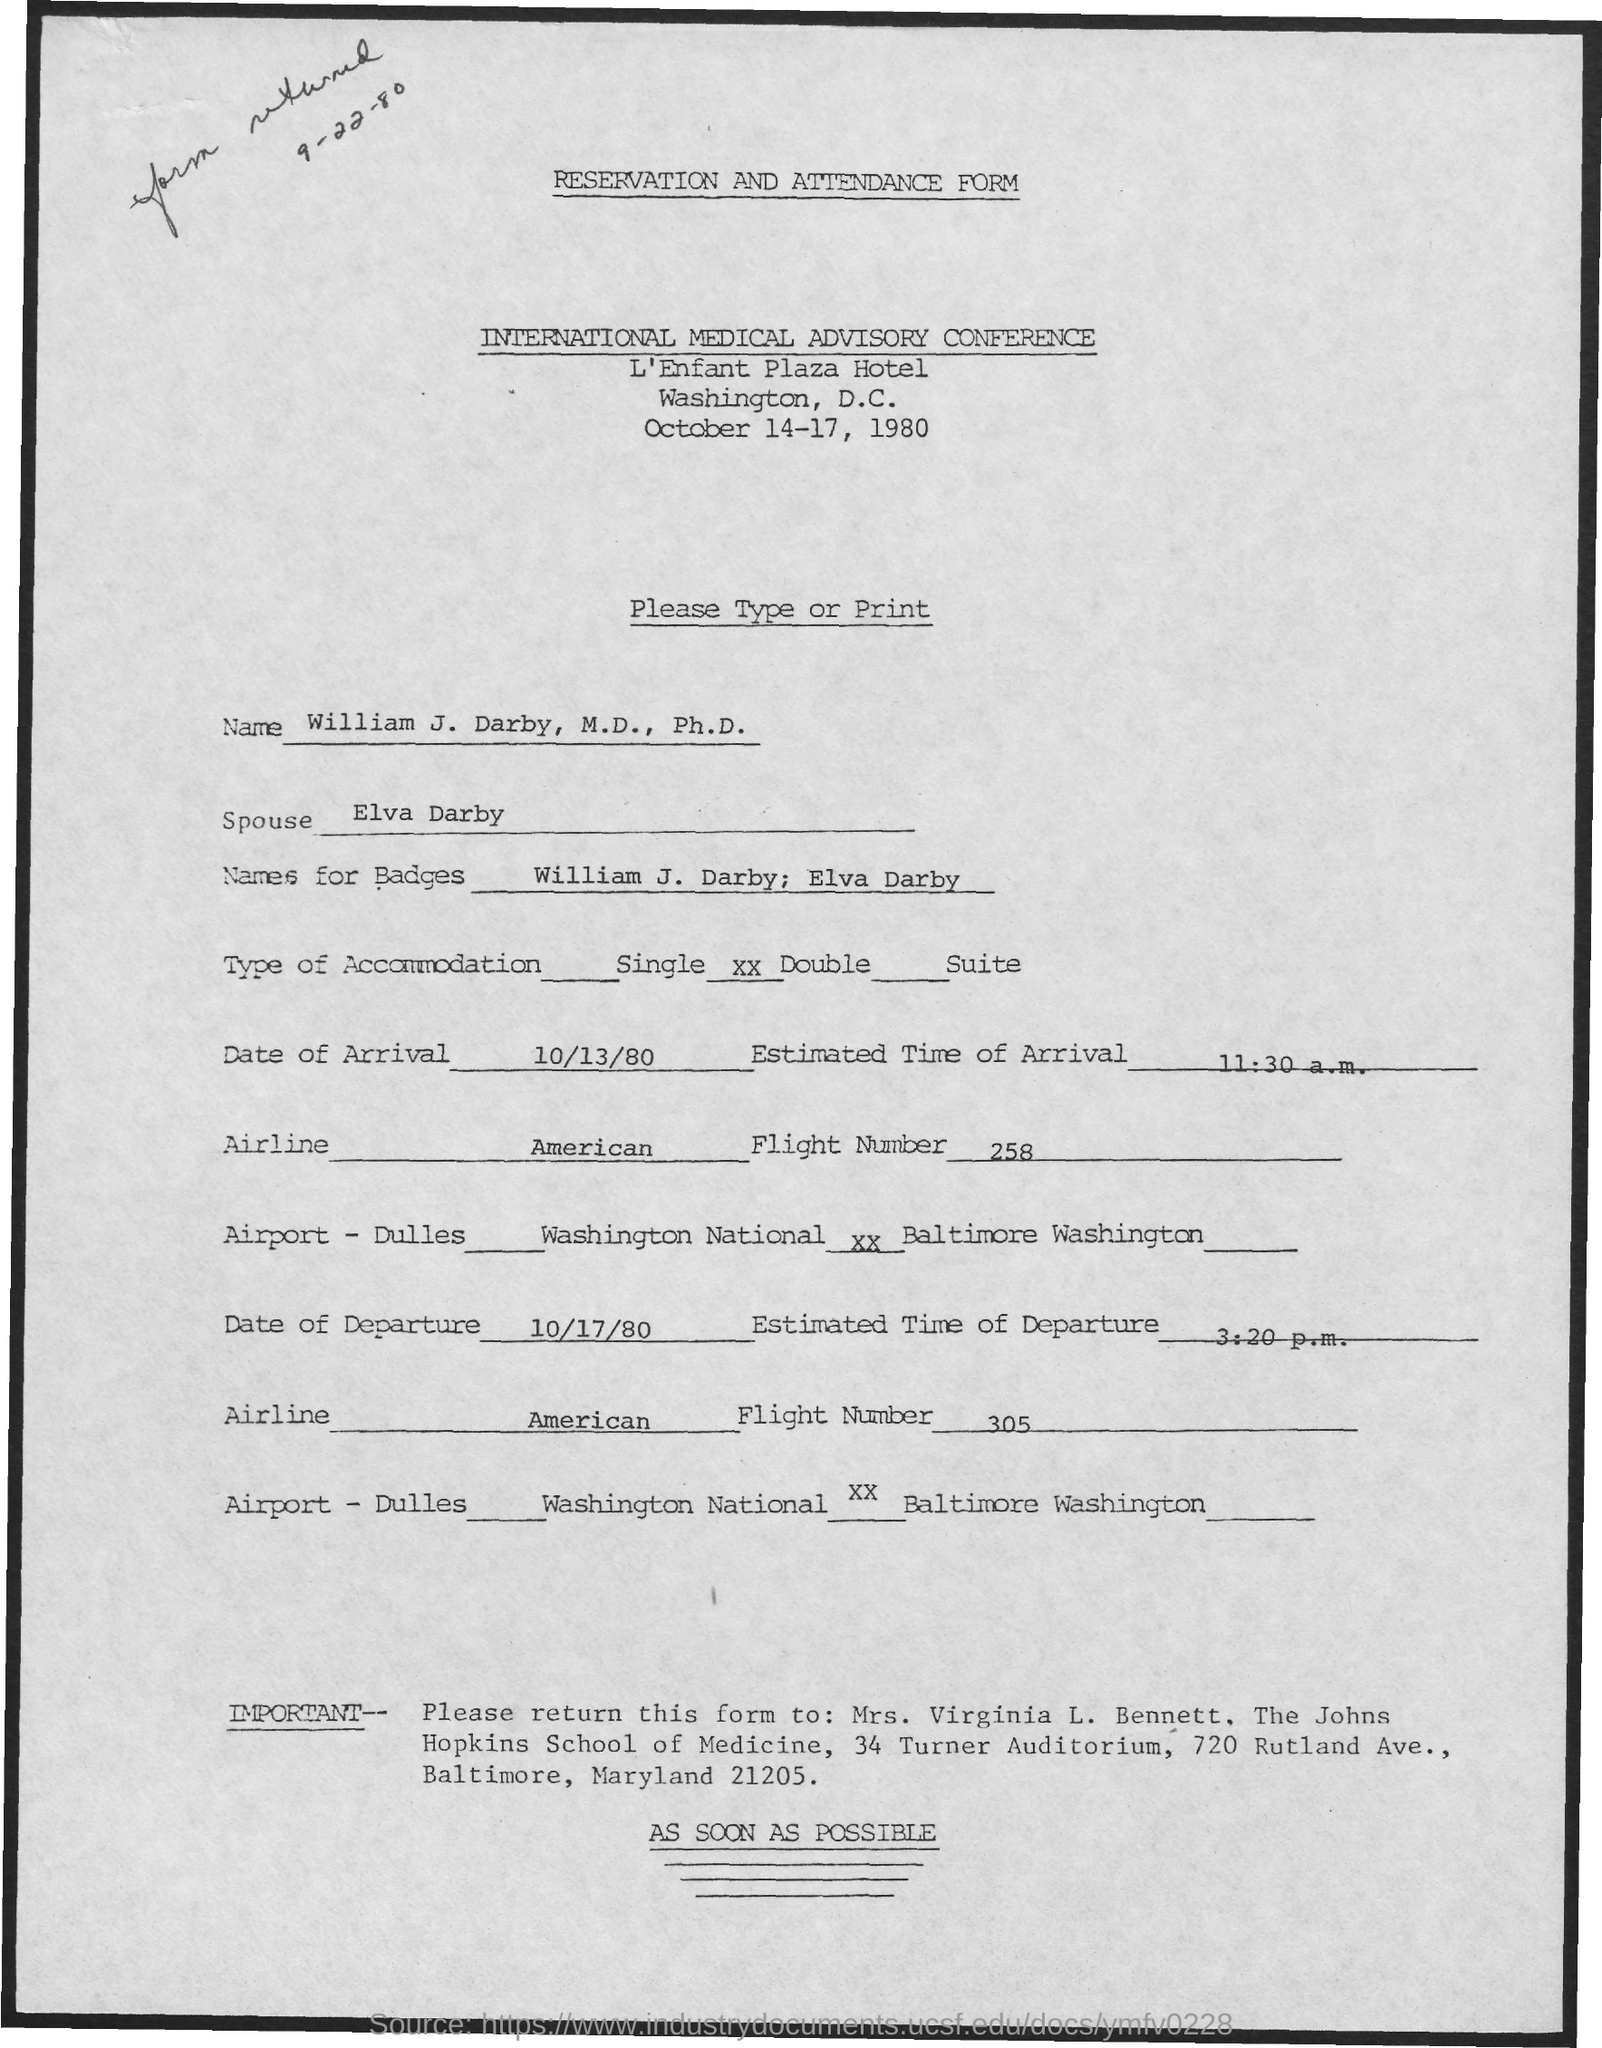Identify some key points in this picture. The arrival is scheduled for 10/13/80. The departure flight number is 305. The type of accommodation is double. The name of the conference is the INTERNATIONAL MEDICAL ADVISORY CONFERENCE. This is a reservation and attendance form. 